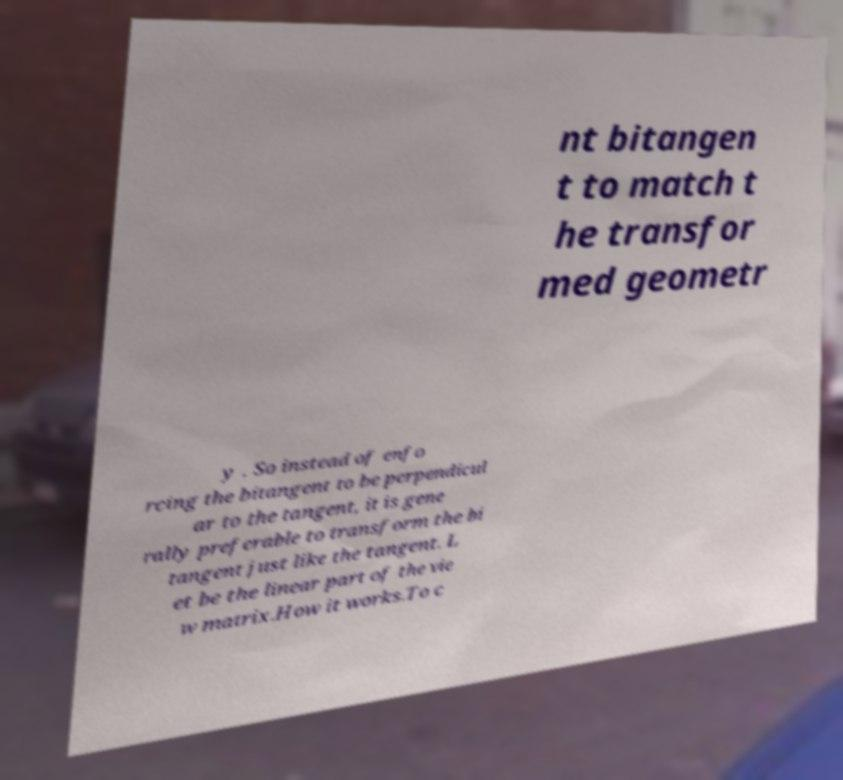Can you accurately transcribe the text from the provided image for me? nt bitangen t to match t he transfor med geometr y . So instead of enfo rcing the bitangent to be perpendicul ar to the tangent, it is gene rally preferable to transform the bi tangent just like the tangent. L et be the linear part of the vie w matrix.How it works.To c 